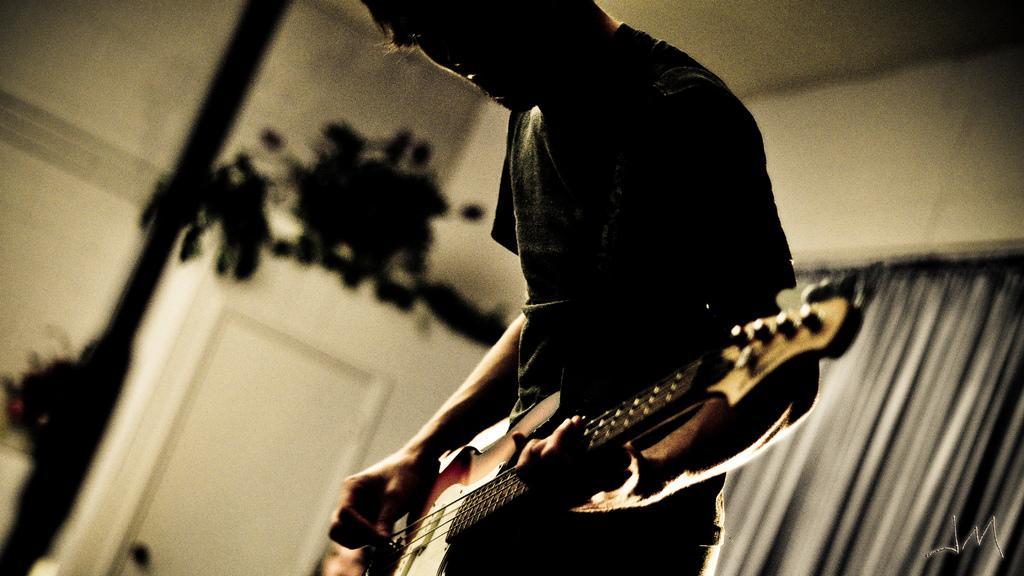Can you describe this image briefly? This picture shows a man standing and playing guitar 